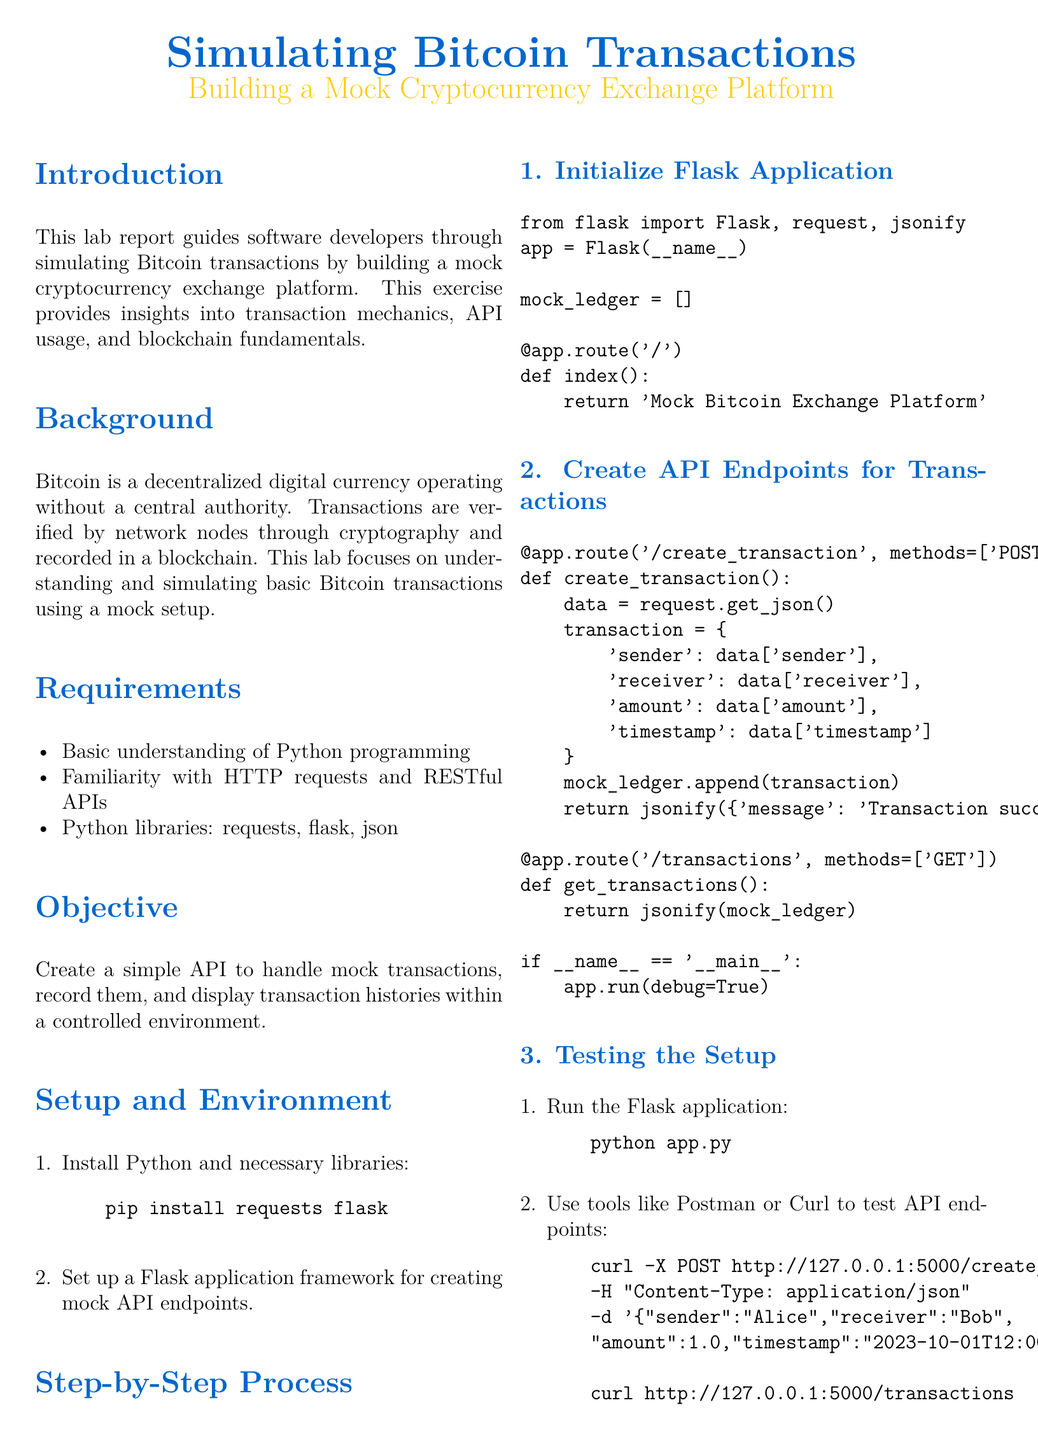what is the title of the lab report? The title of the lab report is clearly stated at the beginning, indicating its focus on simulating Bitcoin transactions.
Answer: Simulating Bitcoin Transactions what Python libraries are required? The document lists the necessary Python libraries needed to implement the mock cryptocurrency exchange.
Answer: requests, flask, json who is the sender in the sample transaction? The sender of the sample transaction, as illustrated in the document, is identified explicitly.
Answer: Alice what is the required understanding for this lab? The report specifies a level of prerequisite knowledge and skills necessary for developers taking on this exercise.
Answer: Basic understanding of Python programming how many main steps are outlined in the process? The document outlines several steps for creating the mock exchange platform, indicating a clear step-by-step approach.
Answer: 3 what does the API endpoint '/create_transaction' do? The purpose of the '/create_transaction' endpoint is clearly stated in the document, revealing its functionality in the mock setup.
Answer: Create a transaction what is the expected outcome of the lab? The document concludes with the anticipated result of completing the lab exercise, summarizing the skills gained.
Answer: A simple mock Bitcoin exchange platform what is the programming framework used for the application? The document specifies the framework used for developing the mock cryptocurrency exchange, highlighting its relevance.
Answer: Flask what is the content type used in the sample curl request? The document provides the content type necessary for making API requests in the example provided.
Answer: application/json 